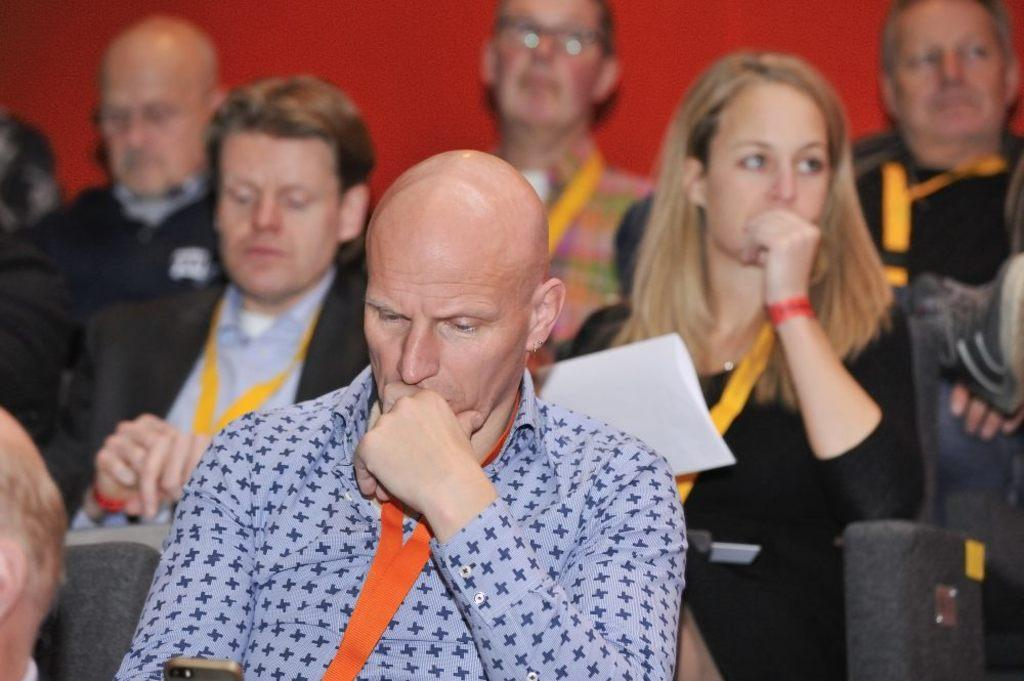What is the color of the background in the image? The background of the picture is red in color. What are the people in the image doing? The people in the image are sitting on chairs. What object can be seen in the image besides the people and chairs? There is a paper in the image. How does the feeling of the beetle affect the people in the image? There is no beetle present in the image, so its feeling cannot affect the people. 